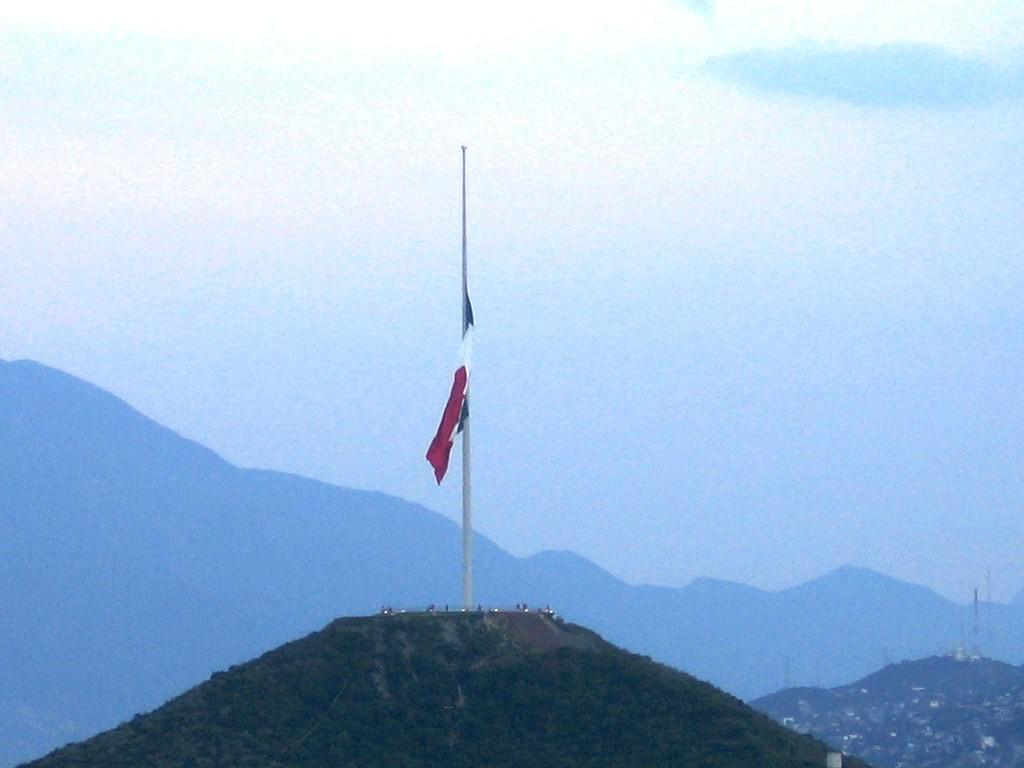What is present in the image that represents a symbol or country? There is a flag in the image. What is the flag attached to in the image? There is a pole in the image that the flag is attached to. Where are the flag and pole located in the image? The flag and pole are on a mountain in the image. What can be seen in the background of the image? Mountains and the sky are visible in the background of the image. What type of vegetation or greenery is present at the bottom of the image? There is greenery at the bottom of the image. What type of love can be seen between the flag and the pole in the image? There is no representation of love between the flag and the pole in the image; they are simply attached to each other. 